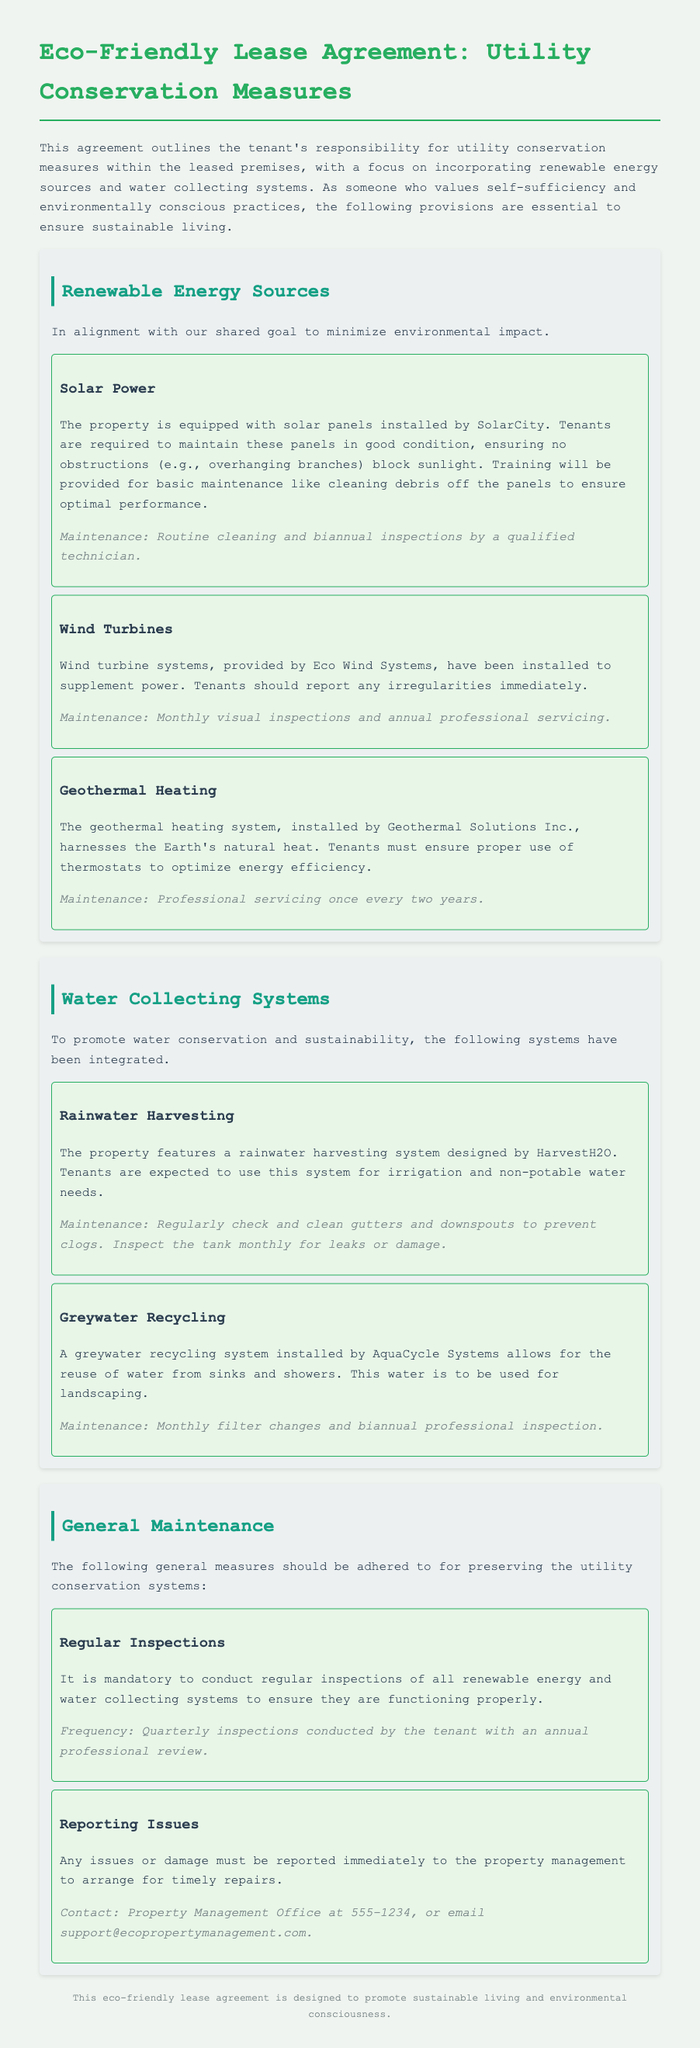what is the title of the document? The title of the document is stated in the header of the agreement, which outlines the purpose and focus of the lease.
Answer: Eco-Friendly Lease Agreement: Utility Conservation Measures who installed the solar panels? The document specifies that SolarCity is the company responsible for the installation of the solar panels.
Answer: SolarCity how often should the wind turbine be inspected? The maintenance section indicates that wind turbines require a specific frequency of inspections to ensure proper functionality.
Answer: Monthly what is the maintenance frequency for the geothermal heating system? The lease makes clear how often professional servicing is required for the geothermal heating system installed in the property.
Answer: Once every two years what should tenants use the rainwater harvesting system for? The document recommends specific uses for the rainwater collected, emphasizing sustainability and conservation.
Answer: Irrigation and non-potable water needs how should issues with the systems be reported? The lease agreement provides a clear method for tenants to report any problems or damages that arise.
Answer: Contact Property Management Office at 555-1234 what is required of tenants in terms of regular inspections? There is a stipulated requirement regarding the frequency at which tenants must conduct inspections of utility systems according to the lease.
Answer: Quarterly inspections who installed the greywater recycling system? The document identifies the company responsible for the installation of the greywater recycling system, which is important for maintenance understanding.
Answer: AquaCycle Systems 